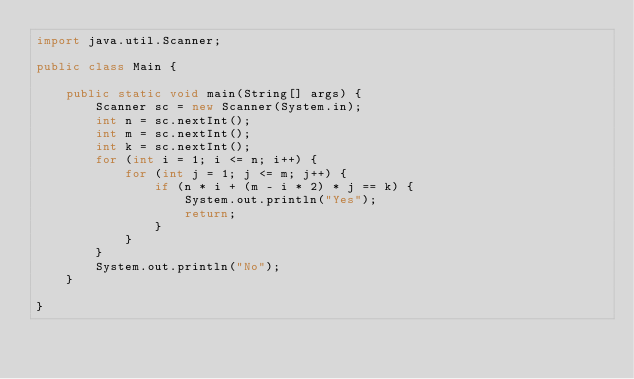<code> <loc_0><loc_0><loc_500><loc_500><_Java_>import java.util.Scanner;

public class Main {

    public static void main(String[] args) {
        Scanner sc = new Scanner(System.in);
        int n = sc.nextInt();
        int m = sc.nextInt();
        int k = sc.nextInt();
        for (int i = 1; i <= n; i++) {
            for (int j = 1; j <= m; j++) {
                if (n * i + (m - i * 2) * j == k) {
                    System.out.println("Yes");
                    return;
                }
            }
        }
        System.out.println("No");
    }

}
</code> 